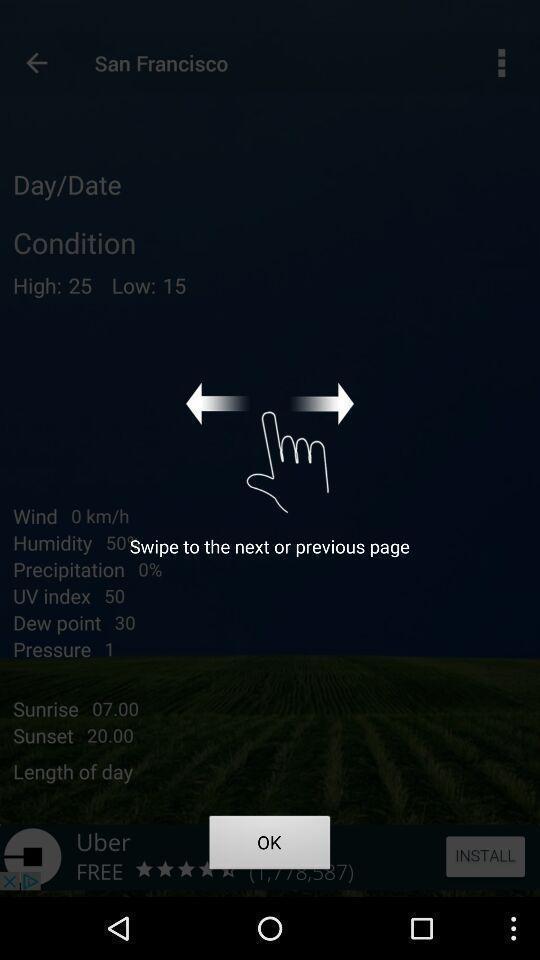Describe the visual elements of this screenshot. Screen displaying demo instructions to access a weather application. 